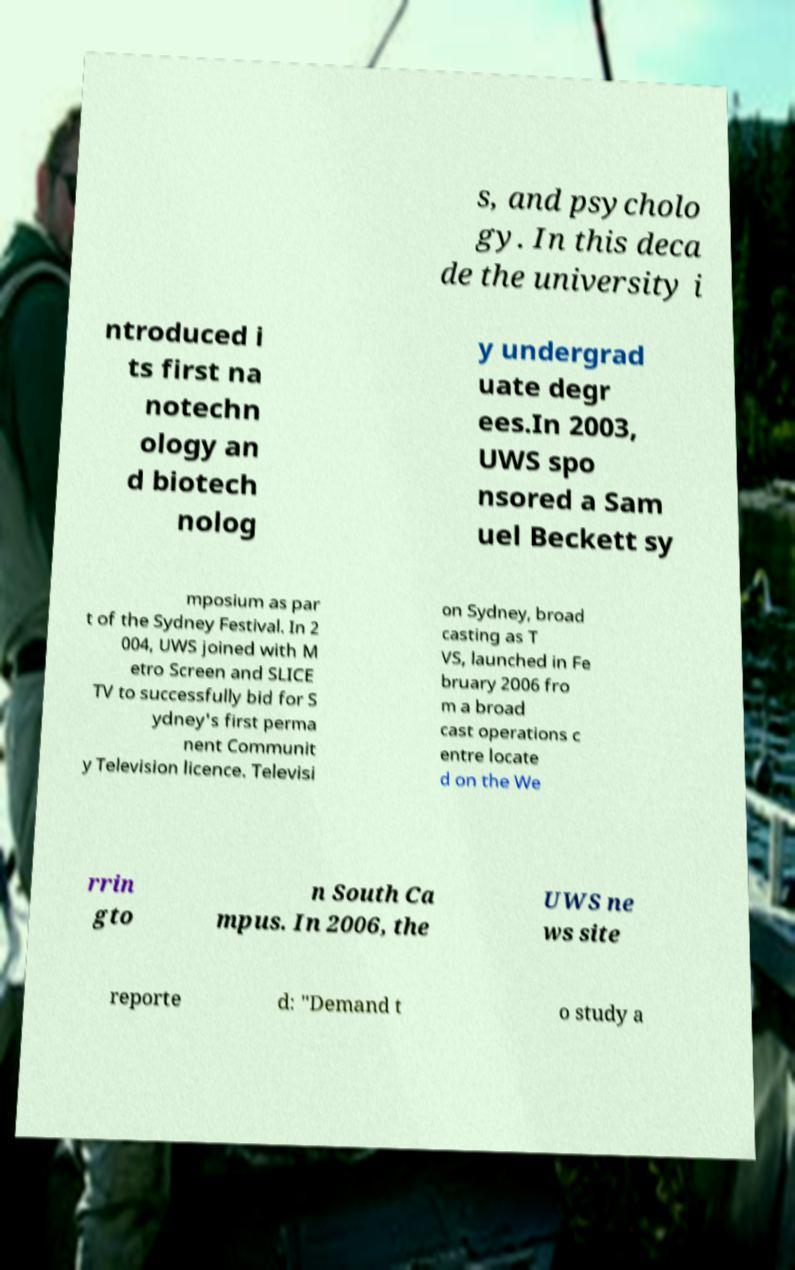Please identify and transcribe the text found in this image. s, and psycholo gy. In this deca de the university i ntroduced i ts first na notechn ology an d biotech nolog y undergrad uate degr ees.In 2003, UWS spo nsored a Sam uel Beckett sy mposium as par t of the Sydney Festival. In 2 004, UWS joined with M etro Screen and SLICE TV to successfully bid for S ydney's first perma nent Communit y Television licence. Televisi on Sydney, broad casting as T VS, launched in Fe bruary 2006 fro m a broad cast operations c entre locate d on the We rrin gto n South Ca mpus. In 2006, the UWS ne ws site reporte d: "Demand t o study a 